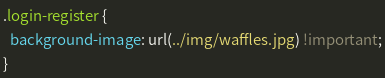<code> <loc_0><loc_0><loc_500><loc_500><_CSS_>.login-register {
  background-image: url(../img/waffles.jpg) !important;
}
</code> 